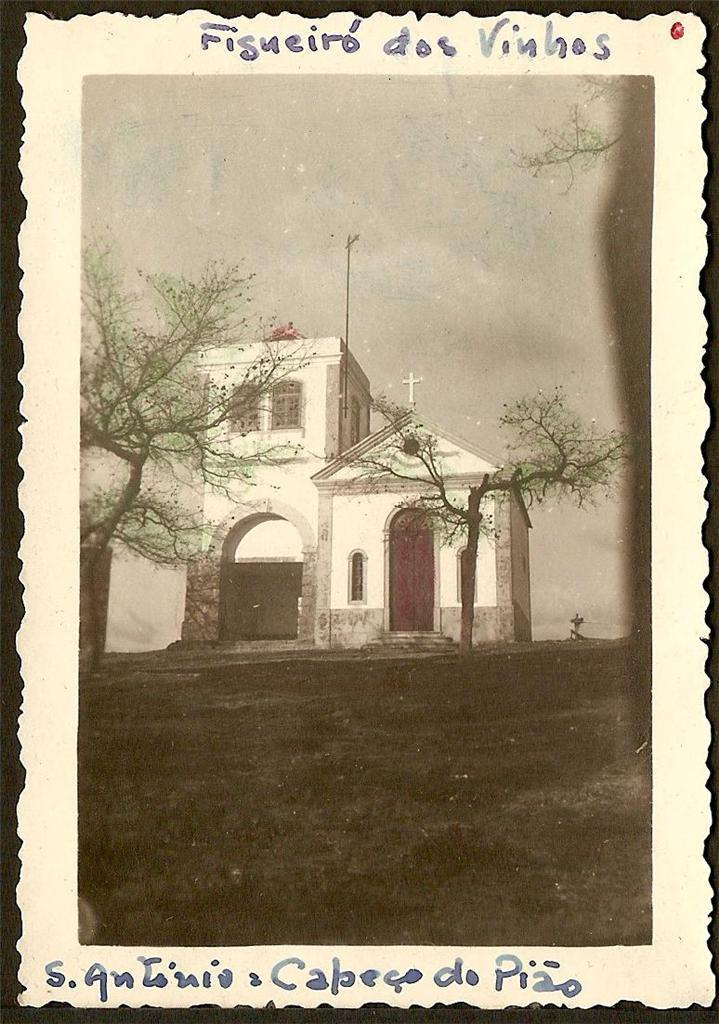What is the main subject of the image? There is a photo in the image. What can be seen in the photo? The photo contains trees and a house with windows. What is visible in the background of the photo? The sky is visible in the background of the photo. What type of coat is the house wearing in the image? The house is not wearing a coat in the image; it is a stationary structure with windows. 